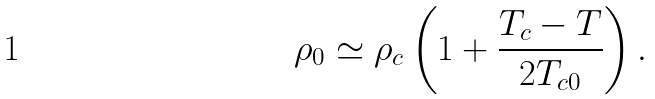<formula> <loc_0><loc_0><loc_500><loc_500>\rho _ { 0 } \simeq \rho _ { c } \left ( 1 + \frac { T _ { c } - T } { 2 T _ { c 0 } } \right ) .</formula> 